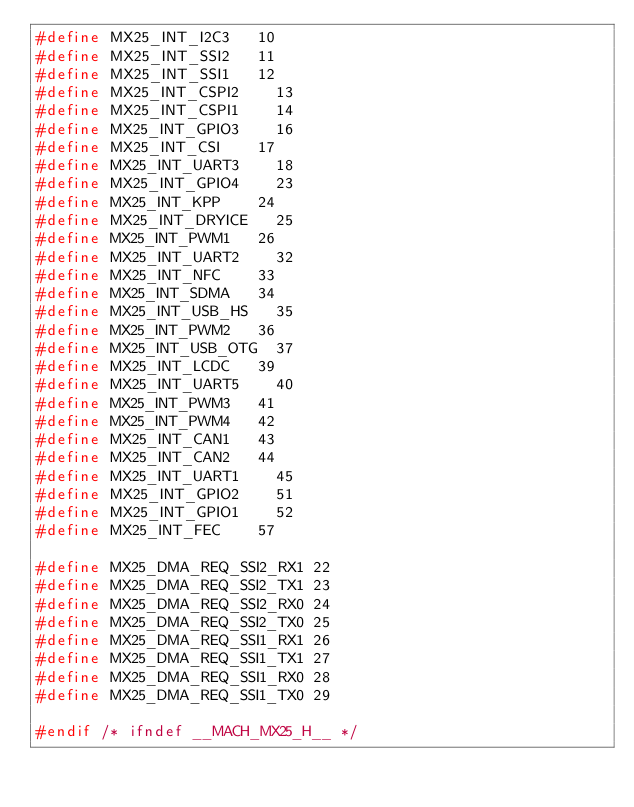Convert code to text. <code><loc_0><loc_0><loc_500><loc_500><_C_>#define MX25_INT_I2C3		10
#define MX25_INT_SSI2		11
#define MX25_INT_SSI1		12
#define MX25_INT_CSPI2		13
#define MX25_INT_CSPI1		14
#define MX25_INT_GPIO3		16
#define MX25_INT_CSI		17
#define MX25_INT_UART3		18
#define MX25_INT_GPIO4		23
#define MX25_INT_KPP		24
#define MX25_INT_DRYICE		25
#define MX25_INT_PWM1		26
#define MX25_INT_UART2		32
#define MX25_INT_NFC		33
#define MX25_INT_SDMA		34
#define MX25_INT_USB_HS		35
#define MX25_INT_PWM2		36
#define MX25_INT_USB_OTG	37
#define MX25_INT_LCDC		39
#define MX25_INT_UART5		40
#define MX25_INT_PWM3		41
#define MX25_INT_PWM4		42
#define MX25_INT_CAN1		43
#define MX25_INT_CAN2		44
#define MX25_INT_UART1		45
#define MX25_INT_GPIO2		51
#define MX25_INT_GPIO1		52
#define MX25_INT_FEC		57

#define MX25_DMA_REQ_SSI2_RX1	22
#define MX25_DMA_REQ_SSI2_TX1	23
#define MX25_DMA_REQ_SSI2_RX0	24
#define MX25_DMA_REQ_SSI2_TX0	25
#define MX25_DMA_REQ_SSI1_RX1	26
#define MX25_DMA_REQ_SSI1_TX1	27
#define MX25_DMA_REQ_SSI1_RX0	28
#define MX25_DMA_REQ_SSI1_TX0	29

#endif /* ifndef __MACH_MX25_H__ */
</code> 